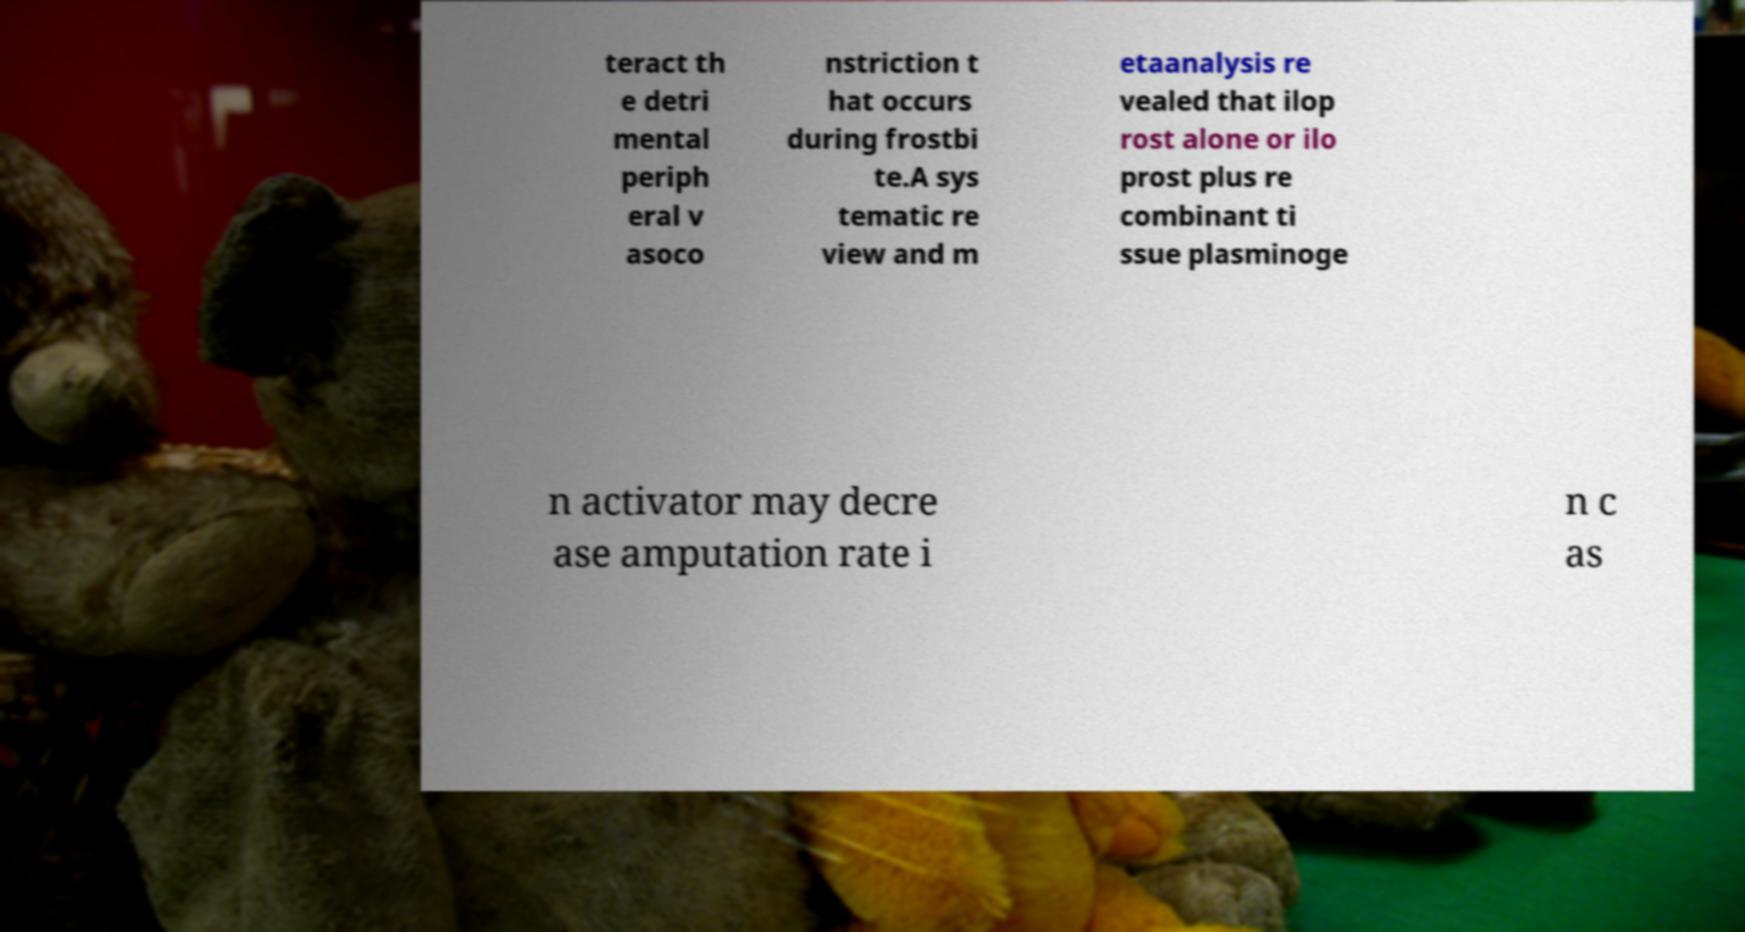Can you accurately transcribe the text from the provided image for me? teract th e detri mental periph eral v asoco nstriction t hat occurs during frostbi te.A sys tematic re view and m etaanalysis re vealed that ilop rost alone or ilo prost plus re combinant ti ssue plasminoge n activator may decre ase amputation rate i n c as 